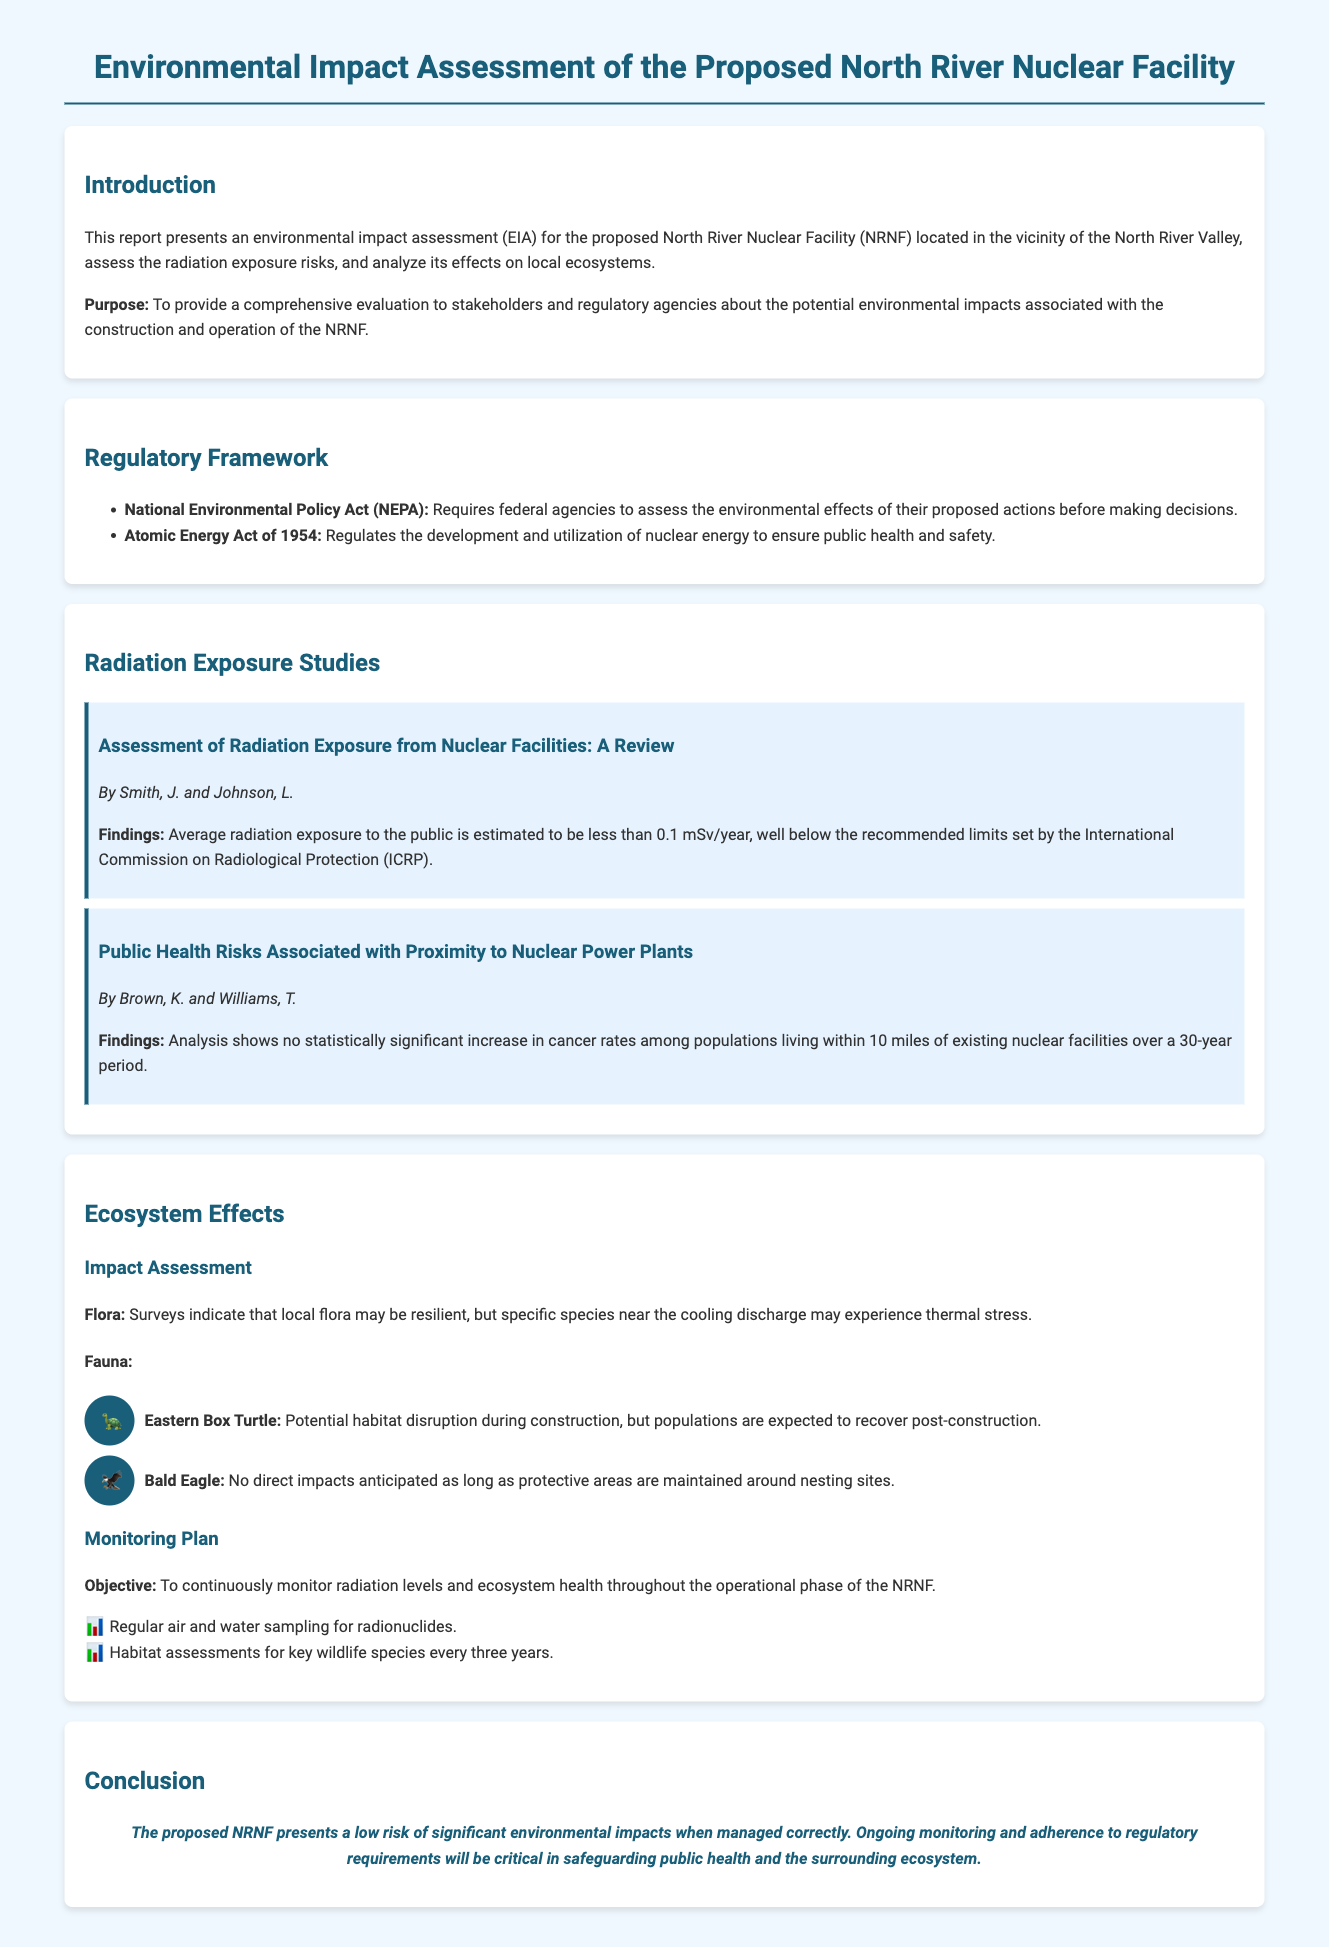what is the location of the proposed nuclear facility? The document states that the facility is located in the vicinity of the North River Valley.
Answer: North River Valley who authored the study on radiation exposure from nuclear facilities? The study was authored by Smith, J. and Johnson, L.
Answer: Smith, J. and Johnson, L what is the average radiation exposure estimate to the public? The average radiation exposure to the public is estimated to be less than 0.1 mSv/year.
Answer: less than 0.1 mSv/year how many years did the cancer rate analysis cover? The analysis on cancer rates covered a period of 30 years.
Answer: 30 years what species is mentioned as having potential habitat disruption during construction? The species mentioned is the Eastern Box Turtle.
Answer: Eastern Box Turtle what is the objective of the monitoring plan? The objective is to continuously monitor radiation levels and ecosystem health throughout the operational phase.
Answer: continuously monitor radiation levels and ecosystem health which regulatory act requires an environmental assessment before decisions? The National Environmental Policy Act (NEPA) requires this assessment.
Answer: National Environmental Policy Act (NEPA) how often will habitat assessments for key wildlife species be conducted? Habitat assessments will be conducted every three years.
Answer: every three years what conclusion is proposed regarding environmental impacts if managed correctly? The conclusion states that the proposed NRNF presents a low risk of significant environmental impacts when managed correctly.
Answer: low risk of significant environmental impacts when managed correctly 